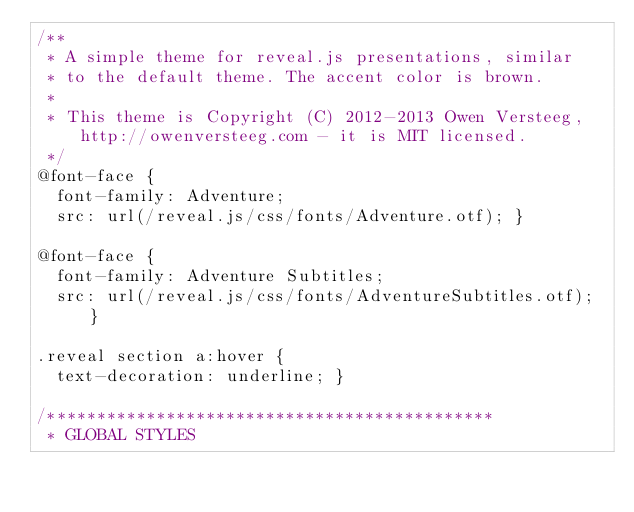Convert code to text. <code><loc_0><loc_0><loc_500><loc_500><_CSS_>/**
 * A simple theme for reveal.js presentations, similar
 * to the default theme. The accent color is brown.
 *
 * This theme is Copyright (C) 2012-2013 Owen Versteeg, http://owenversteeg.com - it is MIT licensed.
 */
@font-face {
  font-family: Adventure;
  src: url(/reveal.js/css/fonts/Adventure.otf); }

@font-face {
  font-family: Adventure Subtitles;
  src: url(/reveal.js/css/fonts/AdventureSubtitles.otf); }

.reveal section a:hover {
  text-decoration: underline; }

/*********************************************
 * GLOBAL STYLES</code> 